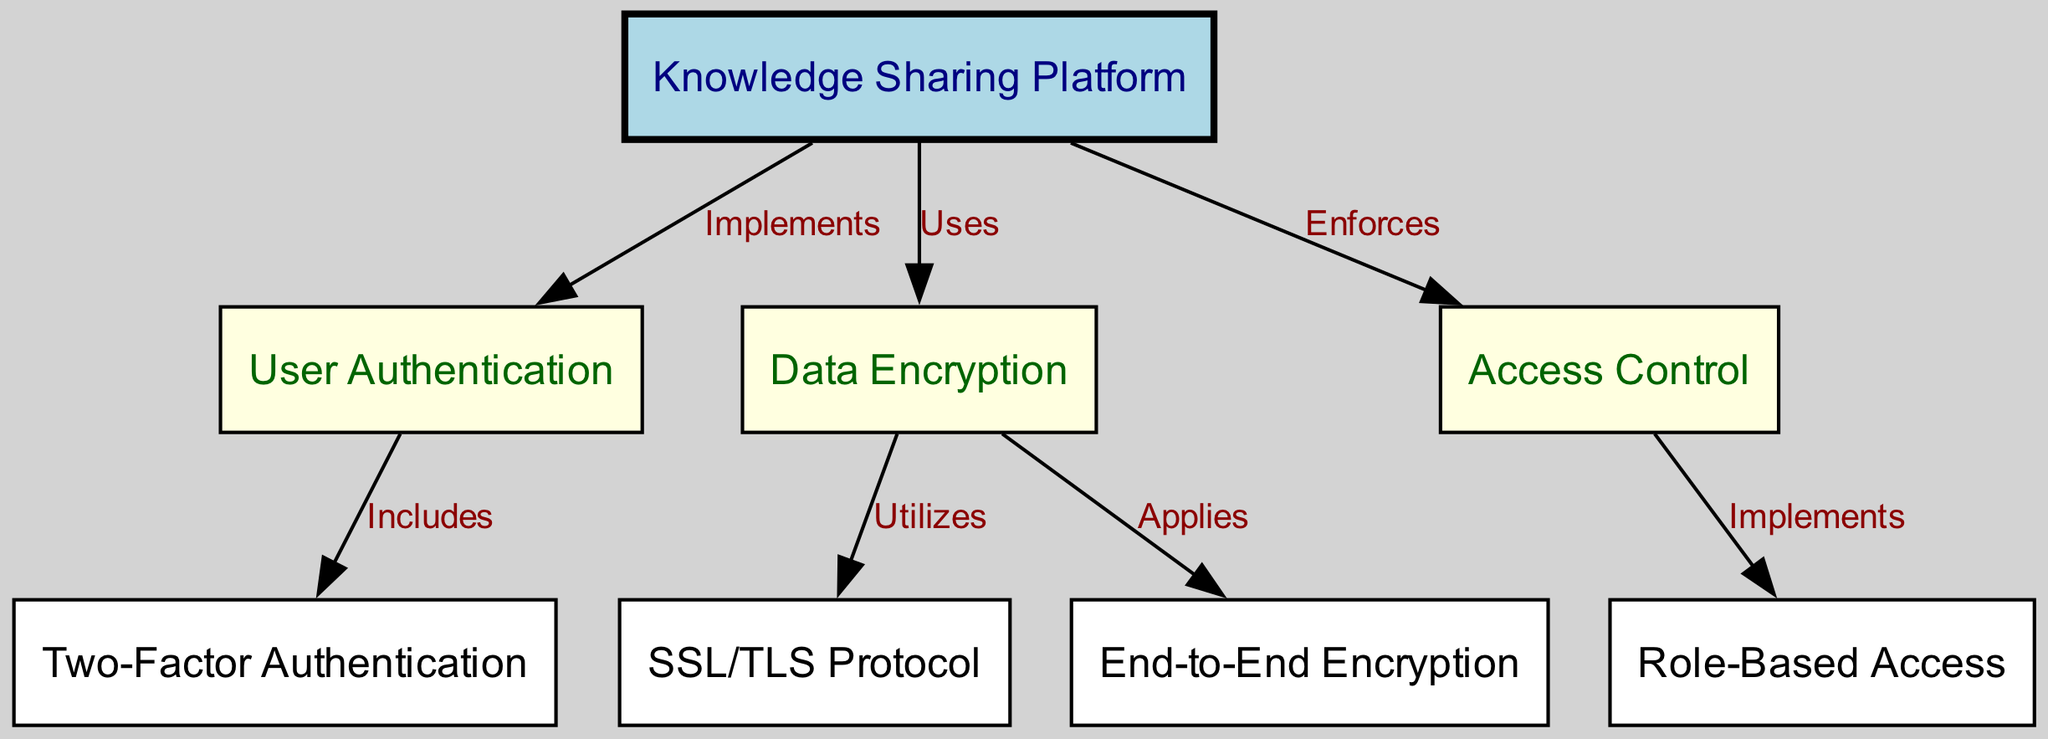What is the primary node in the diagram? The primary node in the diagram is indicated as the starting point, represented by node 1, labeling the entire concept of the "Knowledge Sharing Platform."
Answer: Knowledge Sharing Platform How many edges are there in the diagram? Counting the connections between nodes (represented as edges) in the diagram shows that there are a total of 7 connections.
Answer: 7 What type of authentication method is included as part of user authentication? The diagram specifies that user authentication includes a specific method labeled as Two-Factor Authentication, connected through edge representation.
Answer: Two-Factor Authentication Which protocol is utilized for data encryption? The edge from the Data Encryption node to SSL/TLS Protocol indicates that this specific protocol is utilized for encryption purposes in the diagram.
Answer: SSL/TLS Protocol What access management strategy is implemented for access control? The diagram shows a connection from Access Control to Role-Based Access, indicating that this is the strategy implemented to manage access.
Answer: Role-Based Access What does the Knowledge Sharing Platform enforce? The edges connected to the Knowledge Sharing Platform demonstrate that it enforces user authentication through connection to User Authentication and access control through connection to Access Control.
Answer: User Authentication, Access Control Which encryption method applies end-to-end encryption? In the data encryption node, the connection to the End-to-End Encryption indicates this specific method is applied for securing data throughout its transmission.
Answer: End-to-End Encryption What are the two main components connected to the Data Encryption node? The two main components connected to the Data Encryption node are SSL/TLS Protocol and End-to-End Encryption, as shown by the respective edges.
Answer: SSL/TLS Protocol, End-to-End Encryption 